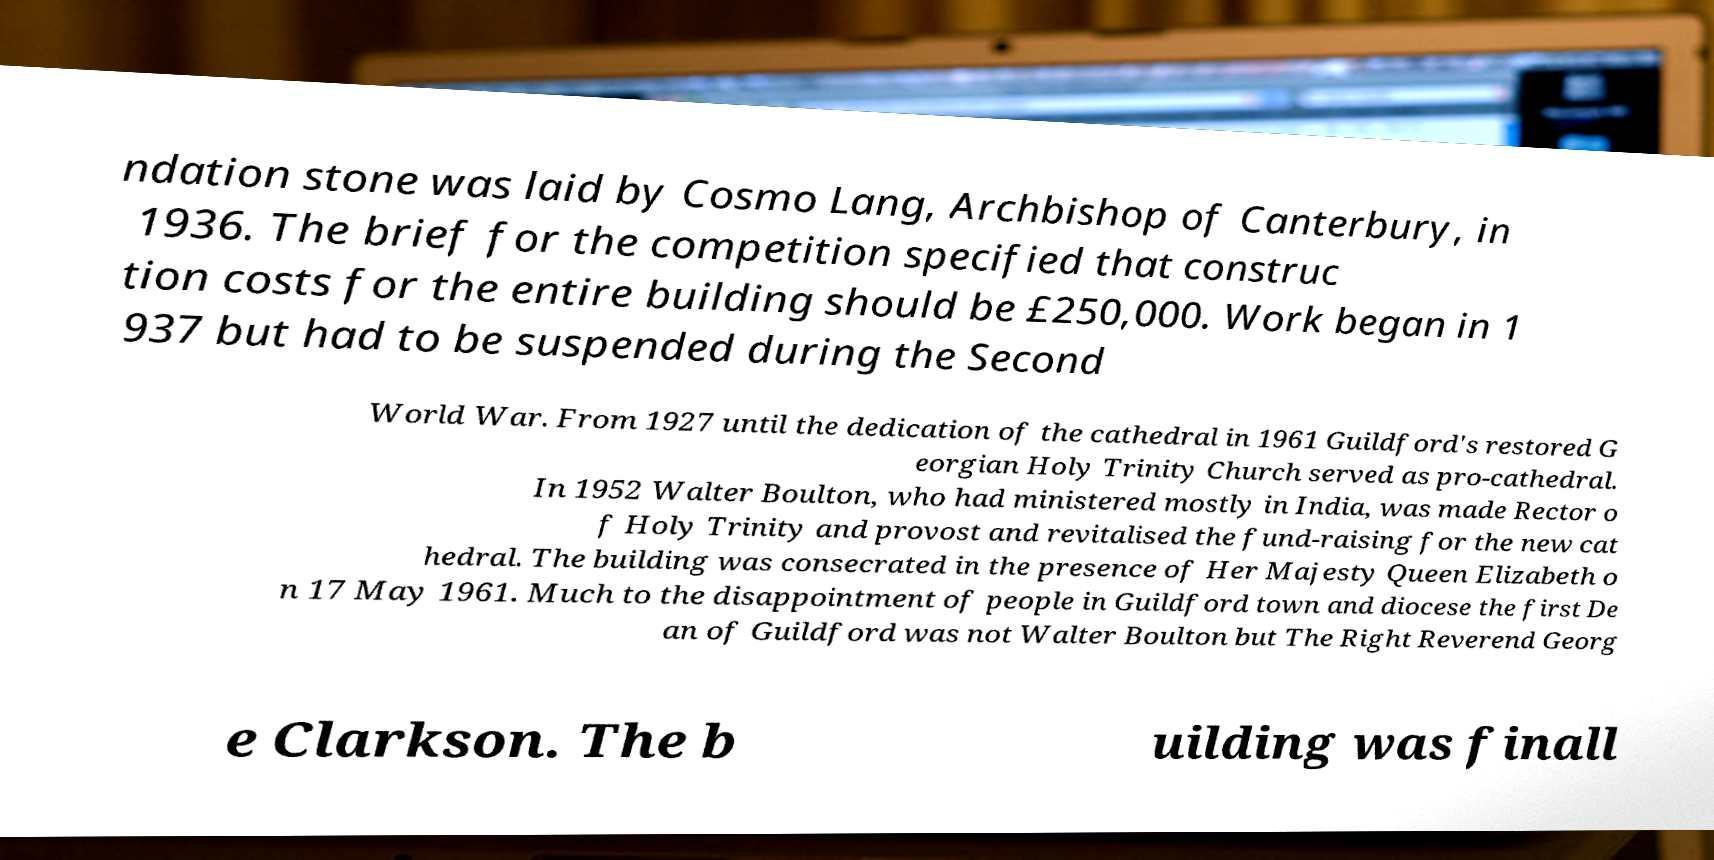Please identify and transcribe the text found in this image. ndation stone was laid by Cosmo Lang, Archbishop of Canterbury, in 1936. The brief for the competition specified that construc tion costs for the entire building should be £250,000. Work began in 1 937 but had to be suspended during the Second World War. From 1927 until the dedication of the cathedral in 1961 Guildford's restored G eorgian Holy Trinity Church served as pro-cathedral. In 1952 Walter Boulton, who had ministered mostly in India, was made Rector o f Holy Trinity and provost and revitalised the fund-raising for the new cat hedral. The building was consecrated in the presence of Her Majesty Queen Elizabeth o n 17 May 1961. Much to the disappointment of people in Guildford town and diocese the first De an of Guildford was not Walter Boulton but The Right Reverend Georg e Clarkson. The b uilding was finall 